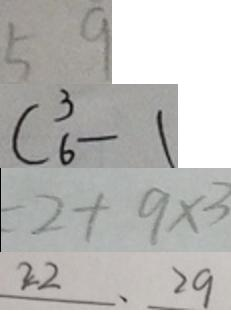<formula> <loc_0><loc_0><loc_500><loc_500>5 9 
 C ^ { 3 } _ { 6 } - 1 
 = 2 + 9 \times 3 
 2 2 、 2 9</formula> 